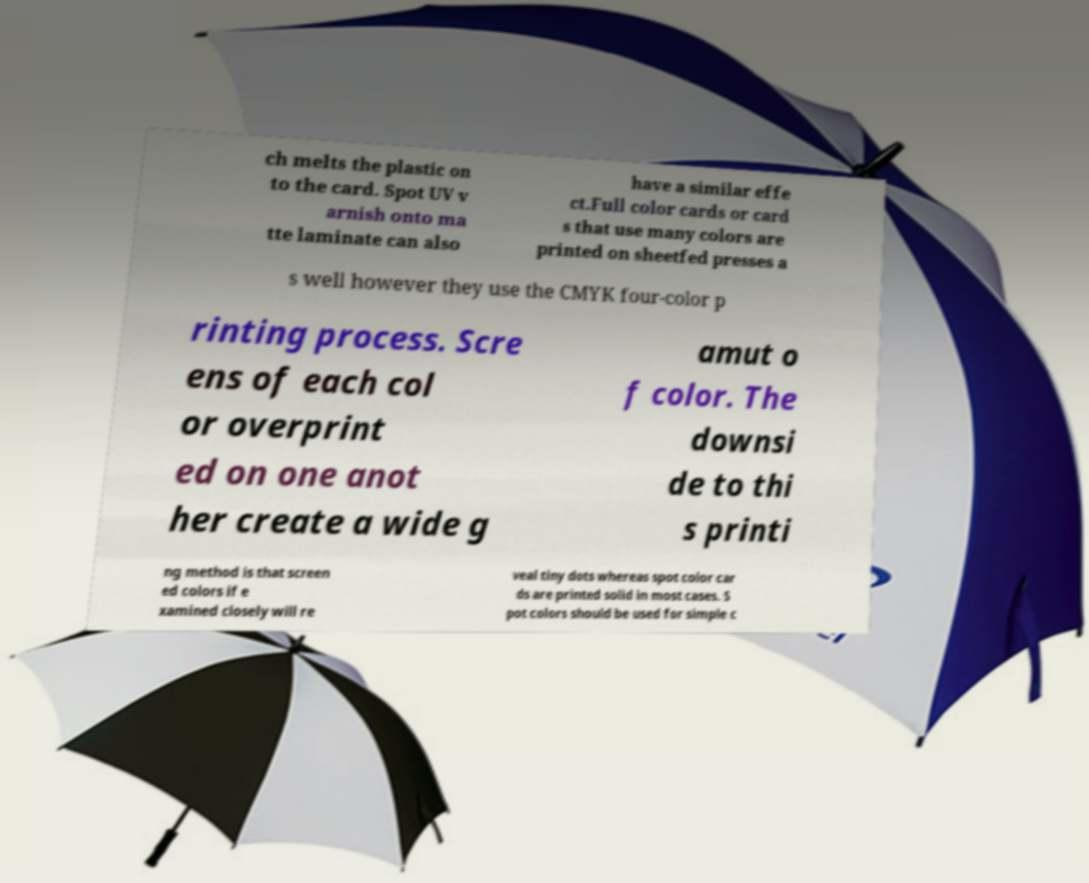For documentation purposes, I need the text within this image transcribed. Could you provide that? ch melts the plastic on to the card. Spot UV v arnish onto ma tte laminate can also have a similar effe ct.Full color cards or card s that use many colors are printed on sheetfed presses a s well however they use the CMYK four-color p rinting process. Scre ens of each col or overprint ed on one anot her create a wide g amut o f color. The downsi de to thi s printi ng method is that screen ed colors if e xamined closely will re veal tiny dots whereas spot color car ds are printed solid in most cases. S pot colors should be used for simple c 